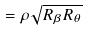Convert formula to latex. <formula><loc_0><loc_0><loc_500><loc_500>= \rho \sqrt { R _ { \beta } R _ { \theta } }</formula> 